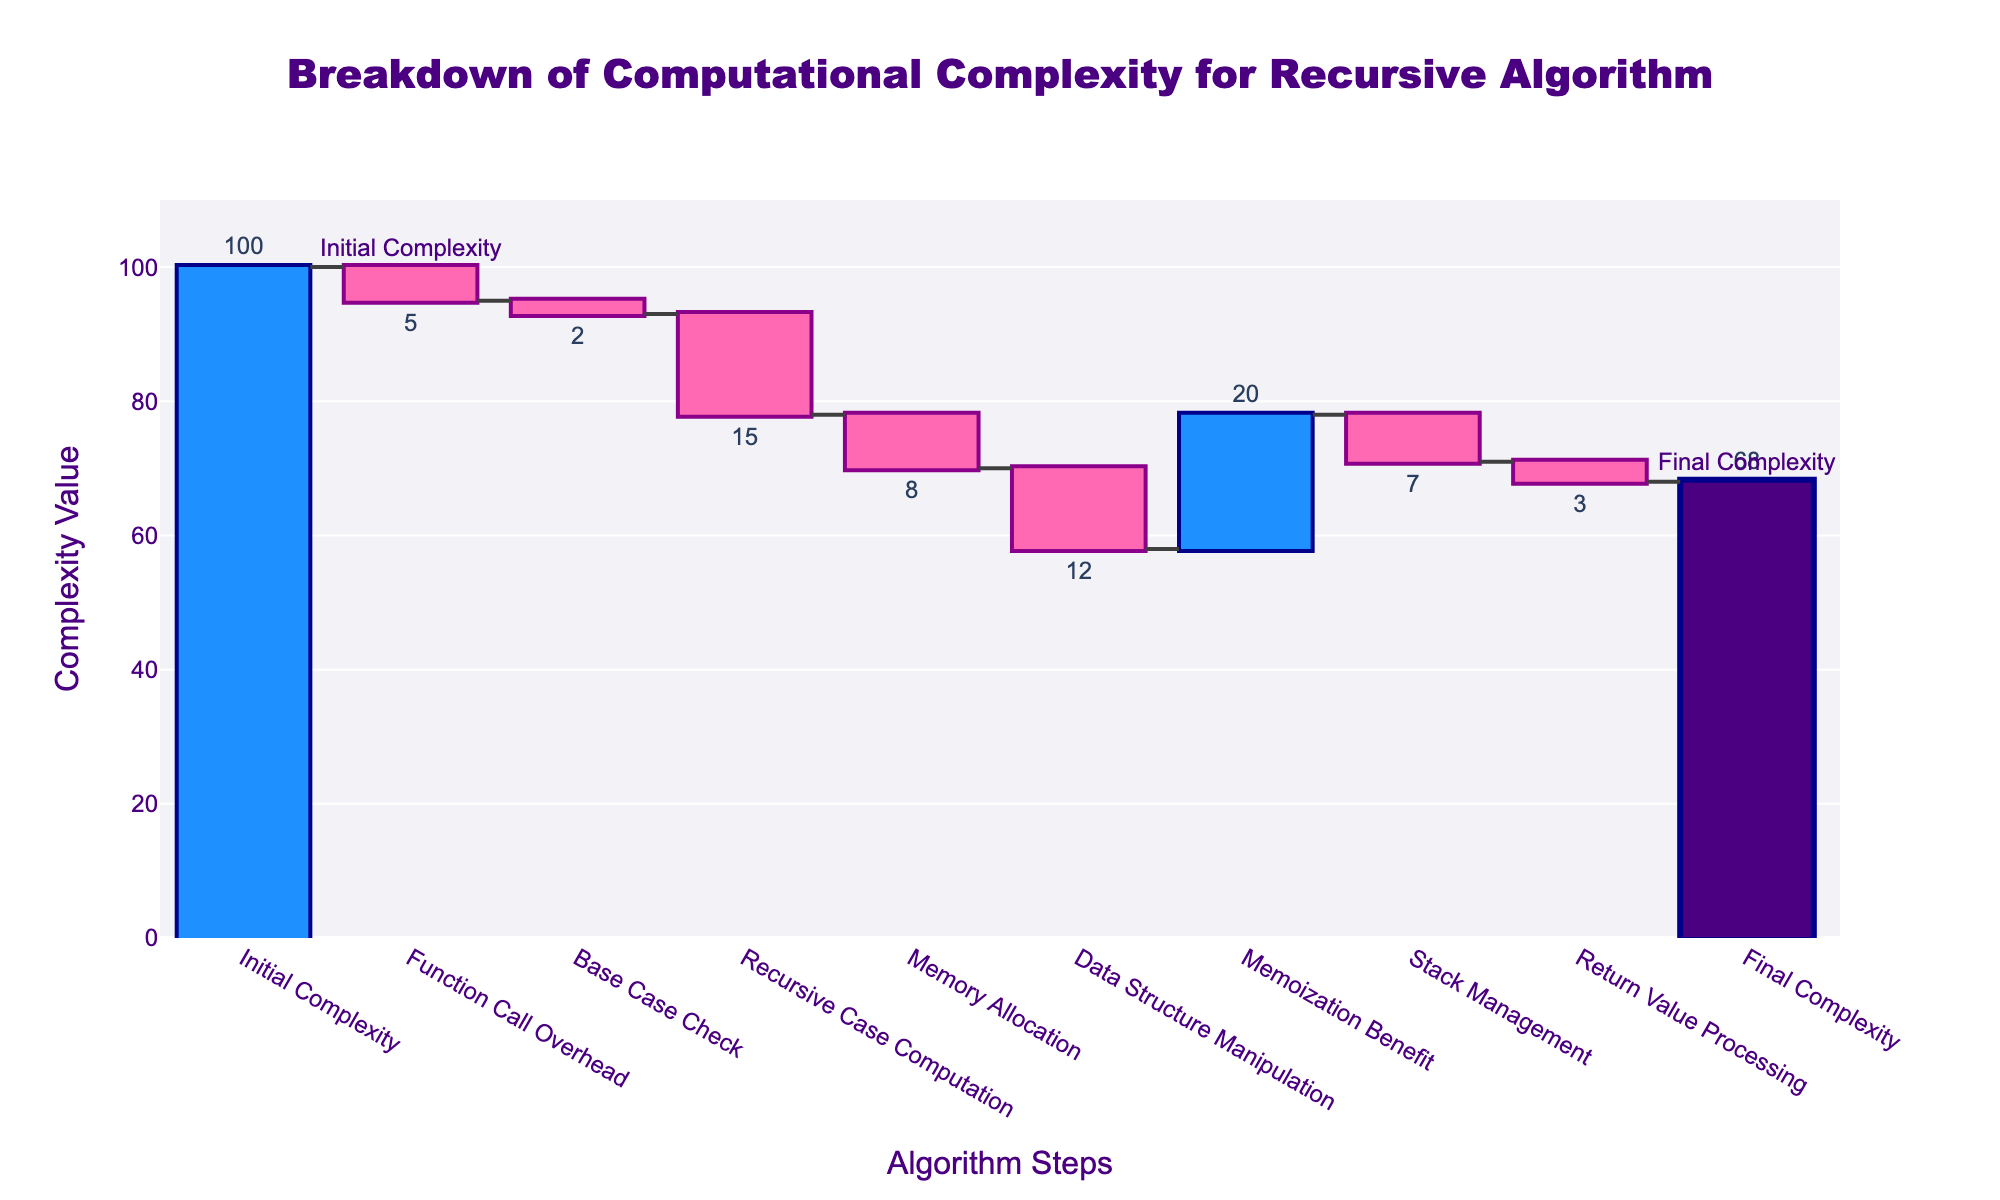What's the title of the chart? The title is displayed prominently at the top of the chart and reads: "Breakdown of Computational Complexity for Recursive Algorithm"
Answer: Breakdown of Computational Complexity for Recursive Algorithm How many steps are involved in the algorithm's breakdown? Counting the number of unique steps on the x-axis of the chart, we identify the total number of steps represented in the computational complexity breakdown.
Answer: 10 What is the highest positive contribution to the final complexity, and what step does it correspond to? The highest positive bar in the chart corresponds to Memoization Benefit and it is indicated by the tallest positive increment.
Answer: Memoization Benefit By how much does "Data Structure Manipulation" decrease the complexity? Observing the value associated with the "Data Structure Manipulation" step, indicated near the corresponding bar, we see the decrease is by 12 units.
Answer: 12 What is the final complexity of the algorithm? The final value is marked on the far right of the chart as "Final Complexity" and noted in the text outside the last bar.
Answer: 68 By looking at the chart, which step has the least impact (either positive or negative) on the computational complexity? Comparing the height of each bar, the smallest impact is indicated by the bar associated with "Base Case Check," as it is the shortest decrement in height.
Answer: Base Case Check What is the cumulative reduction in complexity due to Function Call Overhead, Base Case Check, and Recursive Case Computation? Adding the decrements from these three steps: -5 (Function Call Overhead) + -2 (Base Case Check) + -15 (Recursive Case Computation) gives: -5 - 2 - 15 = -22.
Answer: -22 How does the complexity change due to Memory Allocation compared to Stack Management? The values are -8 for Memory Allocation and -7 for Stack Management. Since both are negative, we look at absolute values to compare their impact; Memory Allocation has a higher absolute value than Stack Management.
Answer: Memory Allocation has a higher negative impact Determine the net impact of all positive contributions to complexity. The only positive contribution is from Memoization Benefit (+20). The net positive impact therefore is +20.
Answer: 20 Calculate the overall decrement in complexity before applying the Memoization Benefit. Summing all negative contributions: -5 (Function Call Overhead) - 2 (Base Case Check) - 15 (Recursive Case Computation) - 8 (Memory Allocation) - 12 (Data Structure Manipulation) - 7 (Stack Management) - 3 (Return Value Processing): -5 -2 -15 -8 -12 -7 -3  = -52.
Answer: -52 